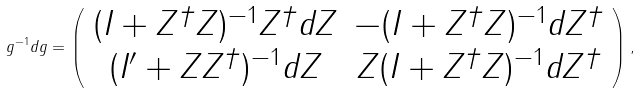Convert formula to latex. <formula><loc_0><loc_0><loc_500><loc_500>g ^ { - 1 } d g = \left ( \begin{array} { c c } ( I + Z ^ { \dag } Z ) ^ { - 1 } Z ^ { \dag } d Z & - ( I + Z ^ { \dag } Z ) ^ { - 1 } d Z ^ { \dag } \\ ( I ^ { \prime } + Z Z ^ { \dag } ) ^ { - 1 } d Z & Z ( I + Z ^ { \dag } Z ) ^ { - 1 } d Z ^ { \dag } \\ \end{array} \right ) ,</formula> 